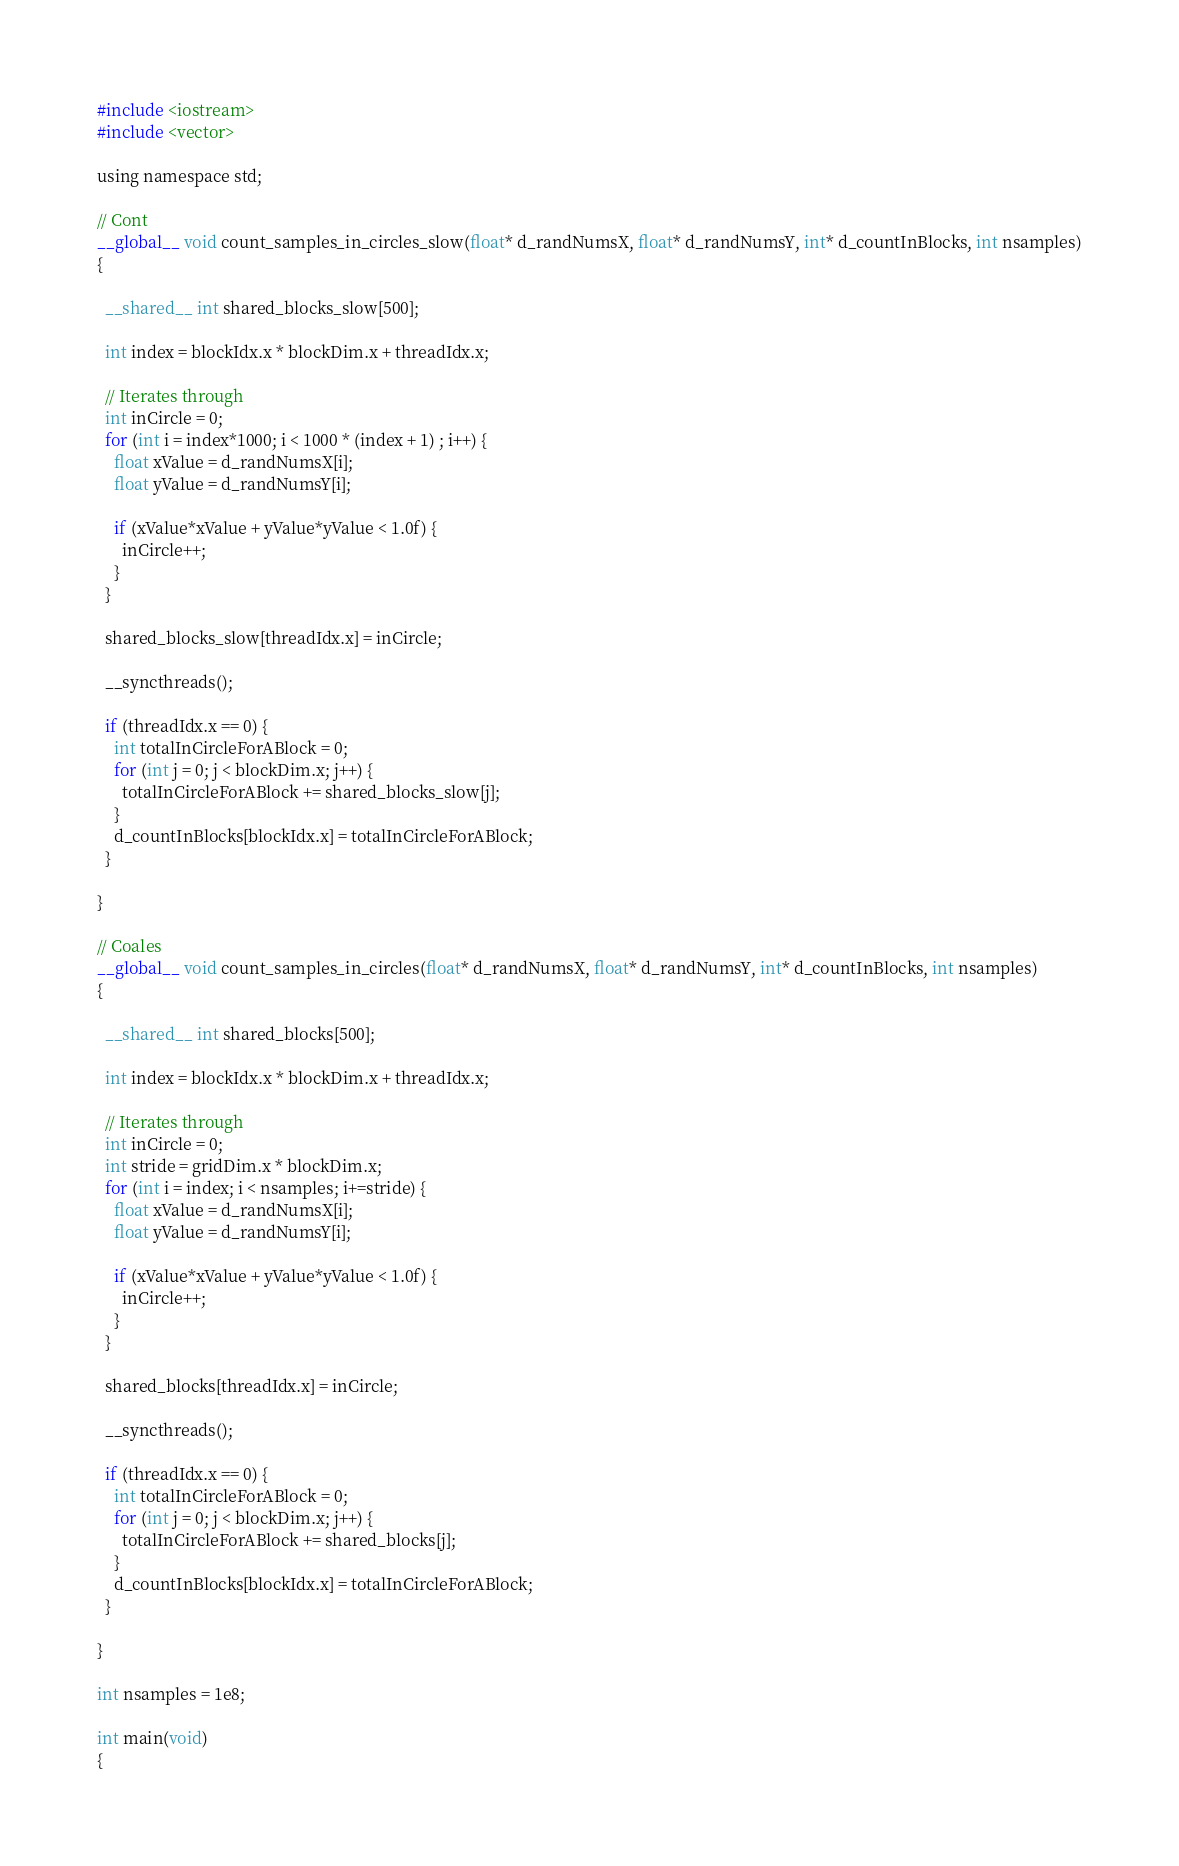Convert code to text. <code><loc_0><loc_0><loc_500><loc_500><_Cuda_>#include <iostream>
#include <vector>

using namespace std;

// Cont
__global__ void count_samples_in_circles_slow(float* d_randNumsX, float* d_randNumsY, int* d_countInBlocks, int nsamples)
{

  __shared__ int shared_blocks_slow[500];

  int index = blockIdx.x * blockDim.x + threadIdx.x;

  // Iterates through
  int inCircle = 0;
  for (int i = index*1000; i < 1000 * (index + 1) ; i++) {
    float xValue = d_randNumsX[i];
    float yValue = d_randNumsY[i];

    if (xValue*xValue + yValue*yValue < 1.0f) {
      inCircle++;
    }
  }

  shared_blocks_slow[threadIdx.x] = inCircle;

  __syncthreads();

  if (threadIdx.x == 0) {
    int totalInCircleForABlock = 0;
    for (int j = 0; j < blockDim.x; j++) {
      totalInCircleForABlock += shared_blocks_slow[j];
    }
    d_countInBlocks[blockIdx.x] = totalInCircleForABlock;
  }

}

// Coales
__global__ void count_samples_in_circles(float* d_randNumsX, float* d_randNumsY, int* d_countInBlocks, int nsamples)
{

  __shared__ int shared_blocks[500];

  int index = blockIdx.x * blockDim.x + threadIdx.x;

  // Iterates through 
  int inCircle = 0;
  int stride = gridDim.x * blockDim.x;
  for (int i = index; i < nsamples; i+=stride) {
    float xValue = d_randNumsX[i];
    float yValue = d_randNumsY[i];

    if (xValue*xValue + yValue*yValue < 1.0f) {
      inCircle++;
    }
  }

  shared_blocks[threadIdx.x] = inCircle;

  __syncthreads();

  if (threadIdx.x == 0) {
    int totalInCircleForABlock = 0;
    for (int j = 0; j < blockDim.x; j++) {
      totalInCircleForABlock += shared_blocks[j];
    }
    d_countInBlocks[blockIdx.x] = totalInCircleForABlock;
  }

}

int nsamples = 1e8;

int main(void)
{</code> 